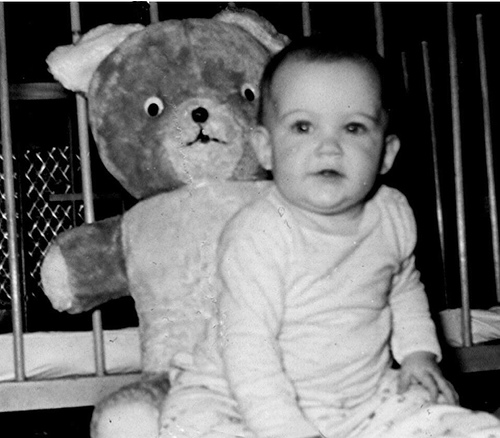<image>Is the baby a boy or a girl? I don't know if the baby is a boy or a girl. The baby could be either a boy or a girl. Is the baby a boy or a girl? It is ambiguous whether the baby is a boy or a girl. 